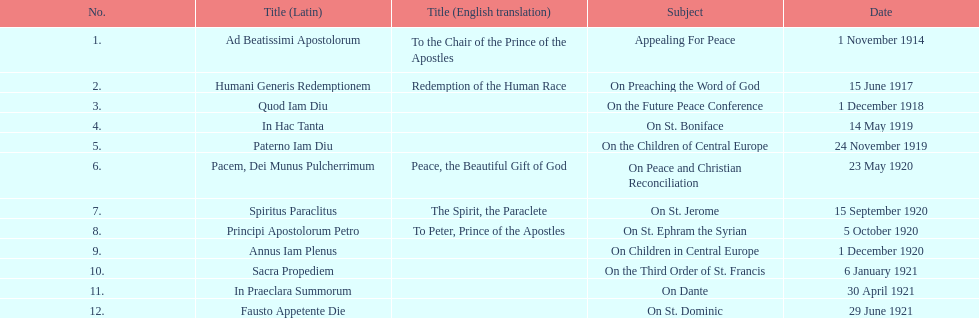How long after quod iam diu was paterno iam diu issued? 11 months. 